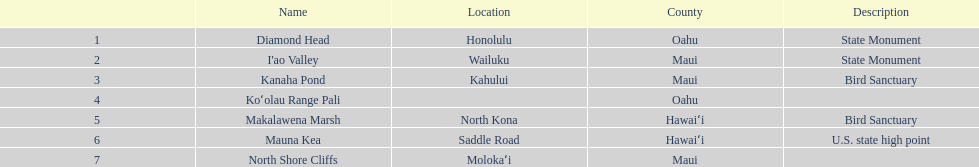How many pictures are enumerated? 6. 